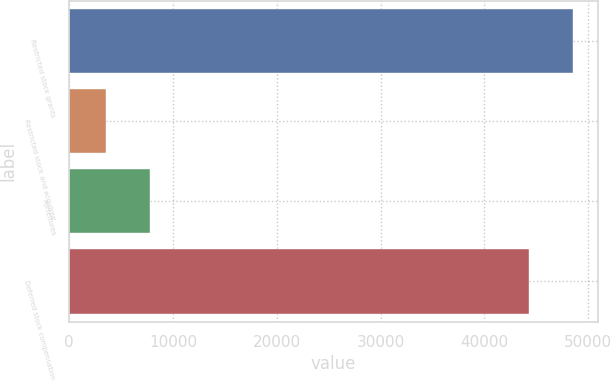Convert chart. <chart><loc_0><loc_0><loc_500><loc_500><bar_chart><fcel>Restricted stock grants<fcel>Restricted stock and acquired<fcel>Forfeitures<fcel>Deferred stock compensation<nl><fcel>48547.2<fcel>3603<fcel>7803.2<fcel>44347<nl></chart> 